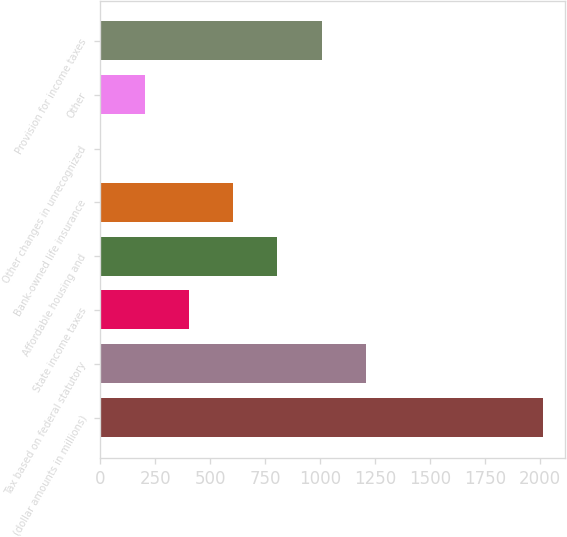Convert chart. <chart><loc_0><loc_0><loc_500><loc_500><bar_chart><fcel>(dollar amounts in millions)<fcel>Tax based on federal statutory<fcel>State income taxes<fcel>Affordable housing and<fcel>Bank-owned life insurance<fcel>Other changes in unrecognized<fcel>Other<fcel>Provision for income taxes<nl><fcel>2013<fcel>1207.88<fcel>402.76<fcel>805.32<fcel>604.04<fcel>0.2<fcel>201.48<fcel>1006.6<nl></chart> 